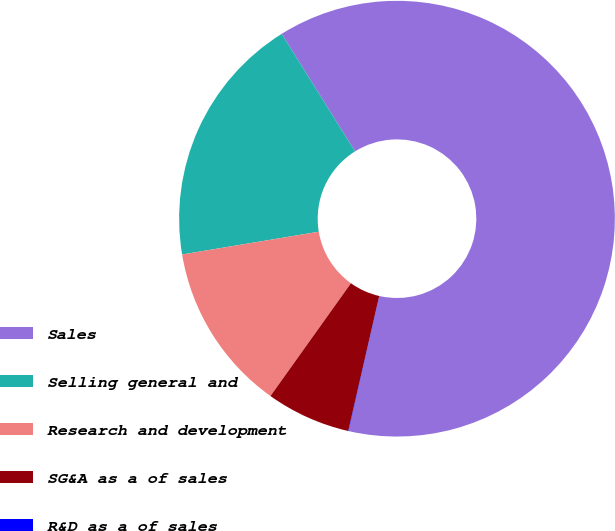Convert chart to OTSL. <chart><loc_0><loc_0><loc_500><loc_500><pie_chart><fcel>Sales<fcel>Selling general and<fcel>Research and development<fcel>SG&A as a of sales<fcel>R&D as a of sales<nl><fcel>62.44%<fcel>18.75%<fcel>12.51%<fcel>6.27%<fcel>0.03%<nl></chart> 